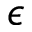<formula> <loc_0><loc_0><loc_500><loc_500>\epsilon</formula> 